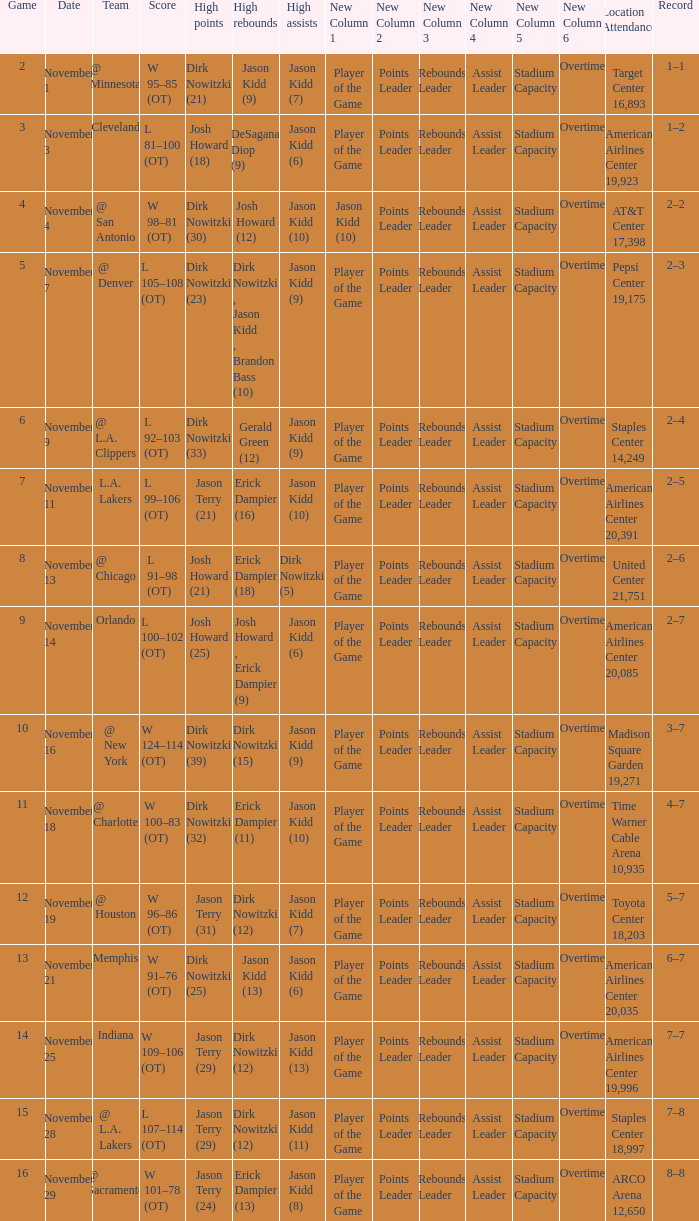What is High Rebounds, when High Assists is "Jason Kidd (13)"? Dirk Nowitzki (12). 